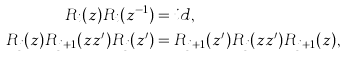<formula> <loc_0><loc_0><loc_500><loc_500>R _ { i } ( z ) R _ { i } ( z ^ { - 1 } ) & = i d , \\ R _ { j } ( z ) R _ { j + 1 } ( z z ^ { \prime } ) R _ { j } ( z ^ { \prime } ) & = R _ { j + 1 } ( z ^ { \prime } ) R _ { j } ( z z ^ { \prime } ) R _ { j + 1 } ( z ) ,</formula> 